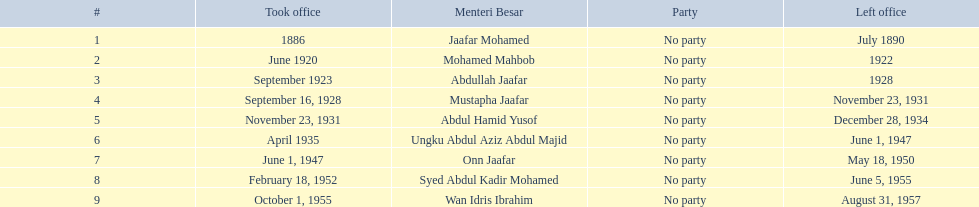Who was in office after mustapha jaafar Abdul Hamid Yusof. 